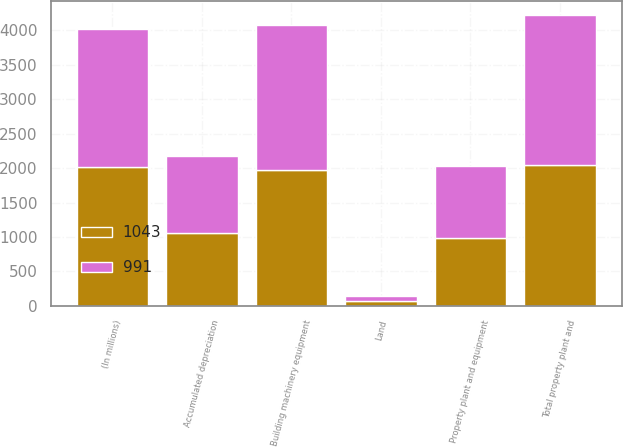Convert chart to OTSL. <chart><loc_0><loc_0><loc_500><loc_500><stacked_bar_chart><ecel><fcel>(In millions)<fcel>Land<fcel>Building machinery equipment<fcel>Total property plant and<fcel>Accumulated depreciation<fcel>Property plant and equipment<nl><fcel>991<fcel>2012<fcel>68<fcel>2107<fcel>2175<fcel>1132<fcel>1043<nl><fcel>1043<fcel>2011<fcel>70<fcel>1973<fcel>2043<fcel>1052<fcel>991<nl></chart> 